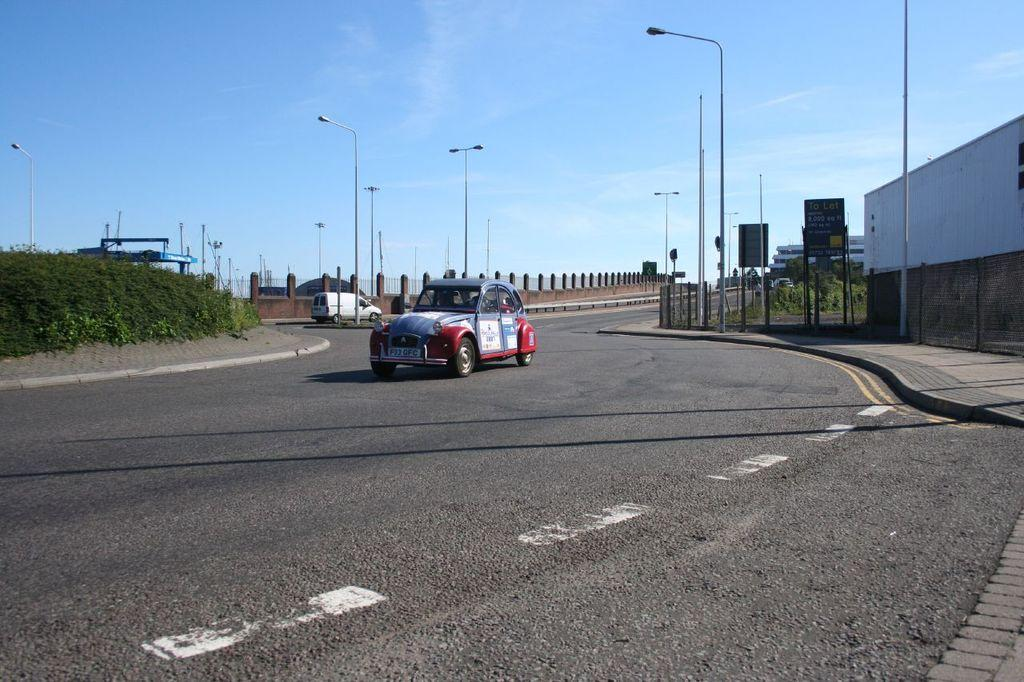How many vehicles can be seen in the image? There are two vehicles in the image. What is the setting of the image? The image features a road, plants, poles, sign boards, boards, pillars, and a walkway. What is visible in the background of the image? The sky is visible in the background of the image. Are there any ghosts visible in the image? There are no ghosts present in the image. What type of appliance can be seen in the image? There are no appliances present in the image. 